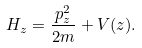Convert formula to latex. <formula><loc_0><loc_0><loc_500><loc_500>H _ { z } = \frac { p _ { z } ^ { 2 } } { 2 m } + V ( z ) .</formula> 